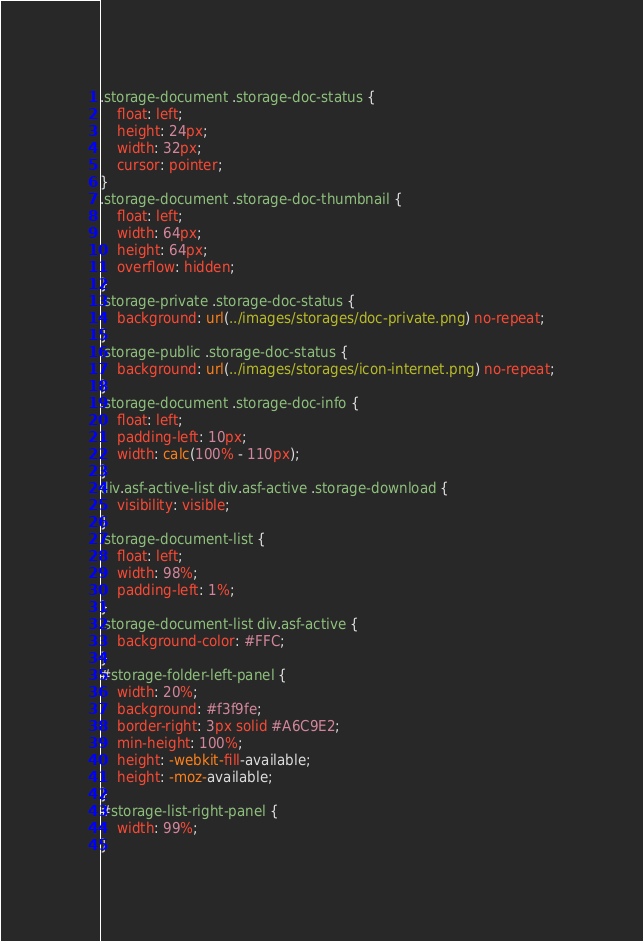Convert code to text. <code><loc_0><loc_0><loc_500><loc_500><_CSS_>.storage-document .storage-doc-status {
    float: left;
    height: 24px;
    width: 32px;
    cursor: pointer;
}
.storage-document .storage-doc-thumbnail {
    float: left;
    width: 64px;
    height: 64px;
    overflow: hidden;
}
.storage-private .storage-doc-status {
    background: url(../images/storages/doc-private.png) no-repeat;
}
.storage-public .storage-doc-status {
    background: url(../images/storages/icon-internet.png) no-repeat;
}
.storage-document .storage-doc-info {
    float: left;
    padding-left: 10px;
    width: calc(100% - 110px);
}
div.asf-active-list div.asf-active .storage-download {
    visibility: visible;
}
.storage-document-list {
    float: left;
    width: 98%;
    padding-left: 1%;
}
.storage-document-list div.asf-active {
    background-color: #FFC;
}
#storage-folder-left-panel {
    width: 20%;
    background: #f3f9fe;
    border-right: 3px solid #A6C9E2;
    min-height: 100%;
    height: -webkit-fill-available;
    height: -moz-available;
}
#storage-list-right-panel {
    width: 99%;
}</code> 